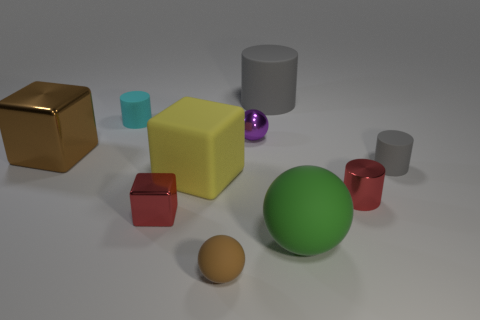There is another big object that is the same shape as the yellow matte object; what color is it?
Ensure brevity in your answer.  Brown. Is there anything else that is the same shape as the big yellow object?
Make the answer very short. Yes. There is a big object on the left side of the yellow matte thing; is it the same shape as the tiny red metallic object that is left of the small brown rubber thing?
Offer a terse response. Yes. Is the size of the green thing the same as the purple ball behind the brown matte thing?
Make the answer very short. No. Is the number of large cyan metallic cubes greater than the number of small gray matte cylinders?
Give a very brief answer. No. Does the red object to the right of the large cylinder have the same material as the large cube behind the tiny gray rubber thing?
Keep it short and to the point. Yes. What material is the cyan cylinder?
Offer a very short reply. Rubber. Is the number of matte things that are to the left of the large rubber block greater than the number of big purple metallic things?
Provide a succinct answer. Yes. What number of cyan cylinders are to the left of the small red metallic object right of the red metal object that is left of the tiny brown sphere?
Your answer should be compact. 1. What is the material of the ball that is behind the brown matte thing and in front of the small gray rubber thing?
Offer a very short reply. Rubber. 